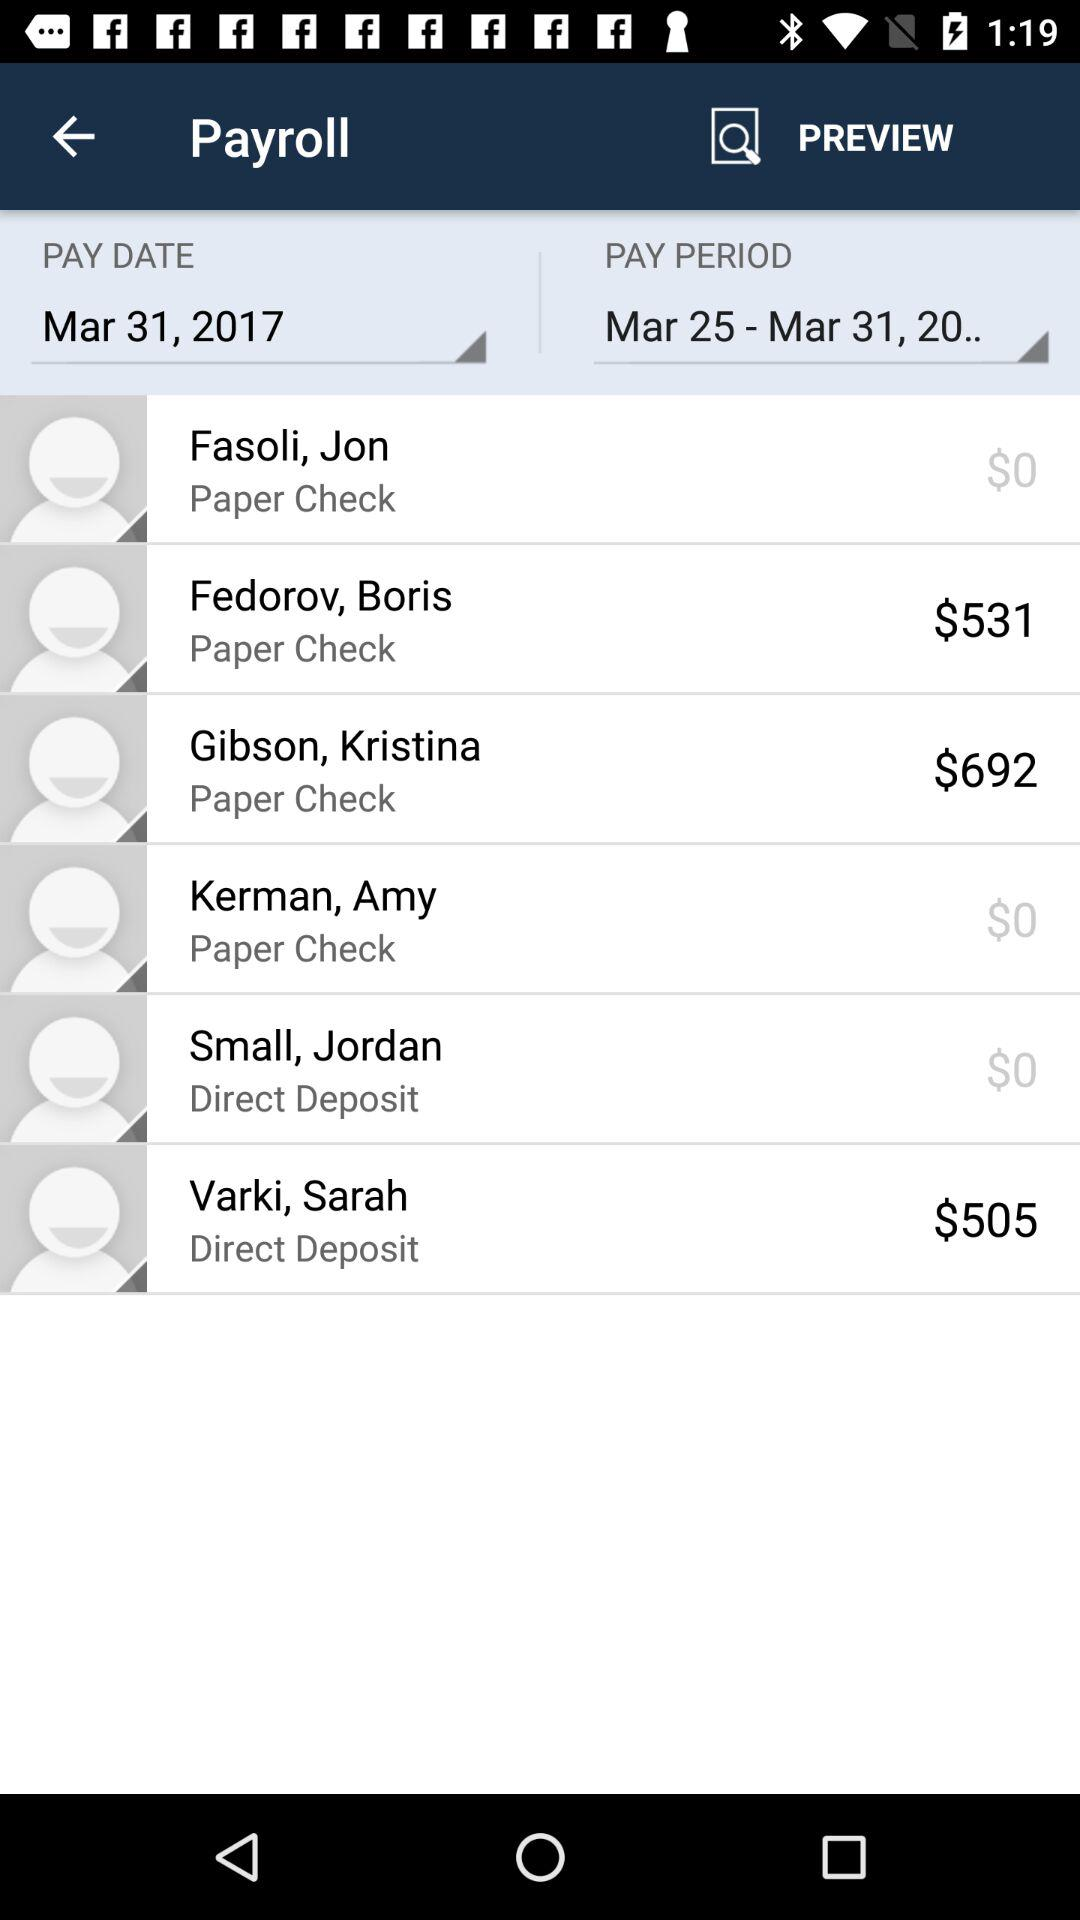What is the pay period date? The pay period date is March 25-March 31, 20.. 